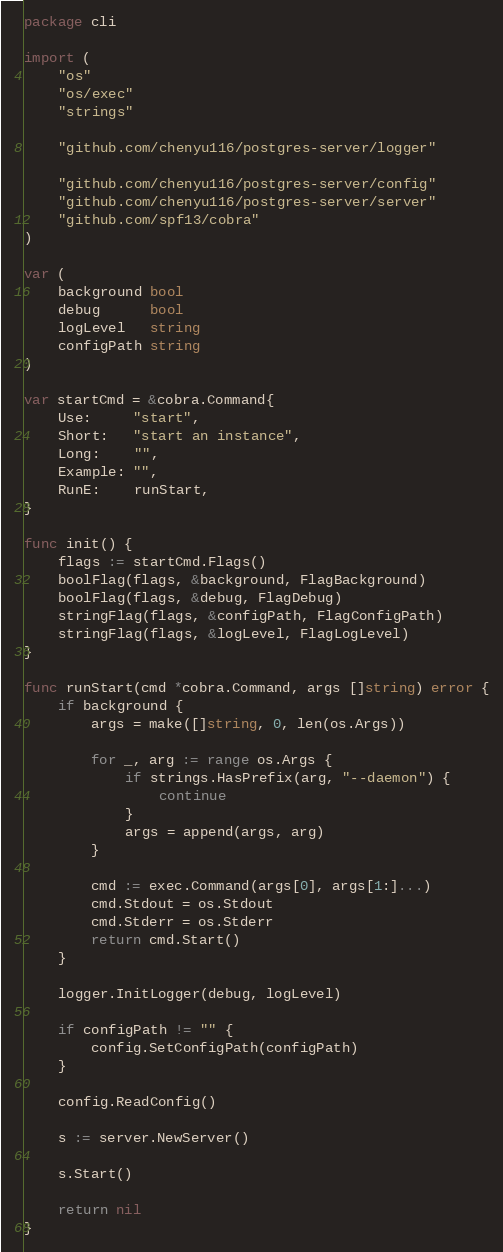<code> <loc_0><loc_0><loc_500><loc_500><_Go_>package cli

import (
	"os"
	"os/exec"
	"strings"

	"github.com/chenyu116/postgres-server/logger"

	"github.com/chenyu116/postgres-server/config"
	"github.com/chenyu116/postgres-server/server"
	"github.com/spf13/cobra"
)

var (
	background bool
	debug      bool
	logLevel   string
	configPath string
)

var startCmd = &cobra.Command{
	Use:     "start",
	Short:   "start an instance",
	Long:    "",
	Example: "",
	RunE:    runStart,
}

func init() {
	flags := startCmd.Flags()
	boolFlag(flags, &background, FlagBackground)
	boolFlag(flags, &debug, FlagDebug)
	stringFlag(flags, &configPath, FlagConfigPath)
	stringFlag(flags, &logLevel, FlagLogLevel)
}

func runStart(cmd *cobra.Command, args []string) error {
	if background {
		args = make([]string, 0, len(os.Args))

		for _, arg := range os.Args {
			if strings.HasPrefix(arg, "--daemon") {
				continue
			}
			args = append(args, arg)
		}

		cmd := exec.Command(args[0], args[1:]...)
		cmd.Stdout = os.Stdout
		cmd.Stderr = os.Stderr
		return cmd.Start()
	}

	logger.InitLogger(debug, logLevel)

	if configPath != "" {
		config.SetConfigPath(configPath)
	}

	config.ReadConfig()

	s := server.NewServer()

	s.Start()

	return nil
}
</code> 